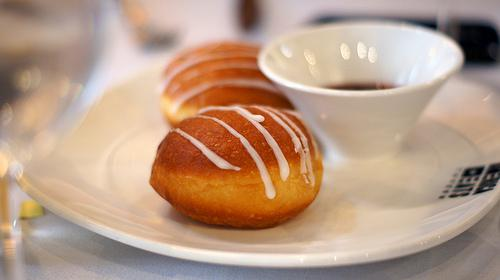Question: where are pastries?
Choices:
A. In the center of the table.
B. At the bakery.
C. Being sold at the counter.
D. On a plate.
Answer with the letter. Answer: D Question: what is white?
Choices:
A. Dish.
B. A plate.
C. Platter.
D. Saucer.
Answer with the letter. Answer: B Question: what is on the plate?
Choices:
A. Pastries.
B. Flowers.
C. Silverware.
D. A napkin.
Answer with the letter. Answer: A Question: how many pastries are on a plate?
Choices:
A. One.
B. Three.
C. Zero.
D. Two.
Answer with the letter. Answer: D Question: where is a plate?
Choices:
A. Up at the counter.
B. On a table.
C. Stacked by the silverware.
D. In front of the guest.
Answer with the letter. Answer: B Question: why are pastries on a plate?
Choices:
A. Displayed.
B. To be eaten.
C. Dessert.
D. For all guest to chose.
Answer with the letter. Answer: B 